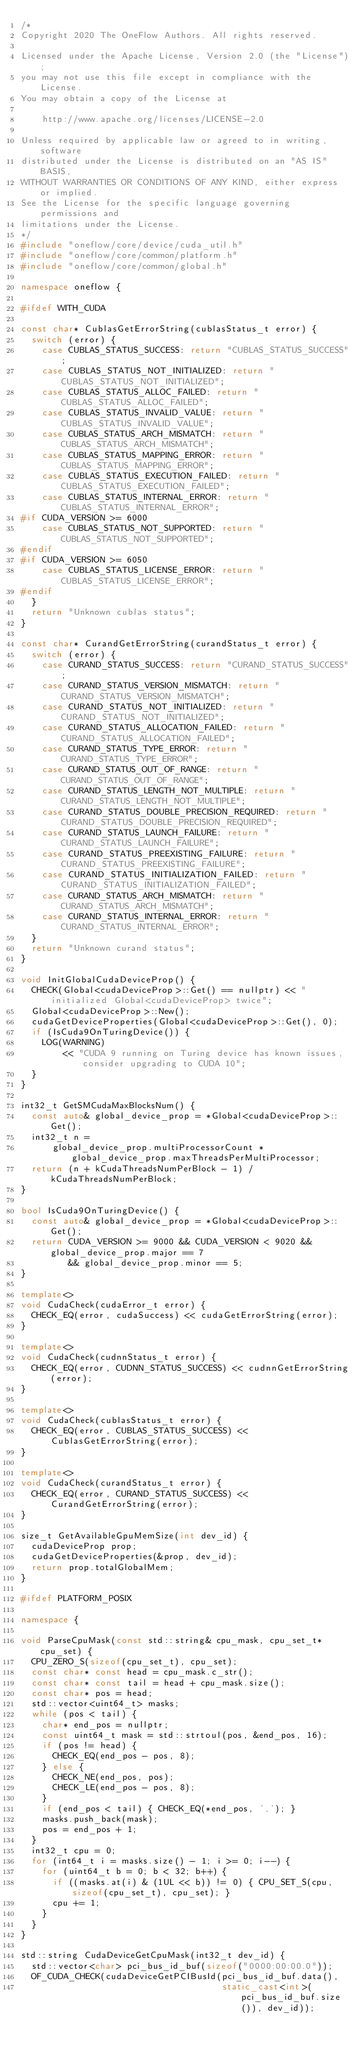Convert code to text. <code><loc_0><loc_0><loc_500><loc_500><_C++_>/*
Copyright 2020 The OneFlow Authors. All rights reserved.

Licensed under the Apache License, Version 2.0 (the "License");
you may not use this file except in compliance with the License.
You may obtain a copy of the License at

    http://www.apache.org/licenses/LICENSE-2.0

Unless required by applicable law or agreed to in writing, software
distributed under the License is distributed on an "AS IS" BASIS,
WITHOUT WARRANTIES OR CONDITIONS OF ANY KIND, either express or implied.
See the License for the specific language governing permissions and
limitations under the License.
*/
#include "oneflow/core/device/cuda_util.h"
#include "oneflow/core/common/platform.h"
#include "oneflow/core/common/global.h"

namespace oneflow {

#ifdef WITH_CUDA

const char* CublasGetErrorString(cublasStatus_t error) {
  switch (error) {
    case CUBLAS_STATUS_SUCCESS: return "CUBLAS_STATUS_SUCCESS";
    case CUBLAS_STATUS_NOT_INITIALIZED: return "CUBLAS_STATUS_NOT_INITIALIZED";
    case CUBLAS_STATUS_ALLOC_FAILED: return "CUBLAS_STATUS_ALLOC_FAILED";
    case CUBLAS_STATUS_INVALID_VALUE: return "CUBLAS_STATUS_INVALID_VALUE";
    case CUBLAS_STATUS_ARCH_MISMATCH: return "CUBLAS_STATUS_ARCH_MISMATCH";
    case CUBLAS_STATUS_MAPPING_ERROR: return "CUBLAS_STATUS_MAPPING_ERROR";
    case CUBLAS_STATUS_EXECUTION_FAILED: return "CUBLAS_STATUS_EXECUTION_FAILED";
    case CUBLAS_STATUS_INTERNAL_ERROR: return "CUBLAS_STATUS_INTERNAL_ERROR";
#if CUDA_VERSION >= 6000
    case CUBLAS_STATUS_NOT_SUPPORTED: return "CUBLAS_STATUS_NOT_SUPPORTED";
#endif
#if CUDA_VERSION >= 6050
    case CUBLAS_STATUS_LICENSE_ERROR: return "CUBLAS_STATUS_LICENSE_ERROR";
#endif
  }
  return "Unknown cublas status";
}

const char* CurandGetErrorString(curandStatus_t error) {
  switch (error) {
    case CURAND_STATUS_SUCCESS: return "CURAND_STATUS_SUCCESS";
    case CURAND_STATUS_VERSION_MISMATCH: return "CURAND_STATUS_VERSION_MISMATCH";
    case CURAND_STATUS_NOT_INITIALIZED: return "CURAND_STATUS_NOT_INITIALIZED";
    case CURAND_STATUS_ALLOCATION_FAILED: return "CURAND_STATUS_ALLOCATION_FAILED";
    case CURAND_STATUS_TYPE_ERROR: return "CURAND_STATUS_TYPE_ERROR";
    case CURAND_STATUS_OUT_OF_RANGE: return "CURAND_STATUS_OUT_OF_RANGE";
    case CURAND_STATUS_LENGTH_NOT_MULTIPLE: return "CURAND_STATUS_LENGTH_NOT_MULTIPLE";
    case CURAND_STATUS_DOUBLE_PRECISION_REQUIRED: return "CURAND_STATUS_DOUBLE_PRECISION_REQUIRED";
    case CURAND_STATUS_LAUNCH_FAILURE: return "CURAND_STATUS_LAUNCH_FAILURE";
    case CURAND_STATUS_PREEXISTING_FAILURE: return "CURAND_STATUS_PREEXISTING_FAILURE";
    case CURAND_STATUS_INITIALIZATION_FAILED: return "CURAND_STATUS_INITIALIZATION_FAILED";
    case CURAND_STATUS_ARCH_MISMATCH: return "CURAND_STATUS_ARCH_MISMATCH";
    case CURAND_STATUS_INTERNAL_ERROR: return "CURAND_STATUS_INTERNAL_ERROR";
  }
  return "Unknown curand status";
}

void InitGlobalCudaDeviceProp() {
  CHECK(Global<cudaDeviceProp>::Get() == nullptr) << "initialized Global<cudaDeviceProp> twice";
  Global<cudaDeviceProp>::New();
  cudaGetDeviceProperties(Global<cudaDeviceProp>::Get(), 0);
  if (IsCuda9OnTuringDevice()) {
    LOG(WARNING)
        << "CUDA 9 running on Turing device has known issues, consider upgrading to CUDA 10";
  }
}

int32_t GetSMCudaMaxBlocksNum() {
  const auto& global_device_prop = *Global<cudaDeviceProp>::Get();
  int32_t n =
      global_device_prop.multiProcessorCount * global_device_prop.maxThreadsPerMultiProcessor;
  return (n + kCudaThreadsNumPerBlock - 1) / kCudaThreadsNumPerBlock;
}

bool IsCuda9OnTuringDevice() {
  const auto& global_device_prop = *Global<cudaDeviceProp>::Get();
  return CUDA_VERSION >= 9000 && CUDA_VERSION < 9020 && global_device_prop.major == 7
         && global_device_prop.minor == 5;
}

template<>
void CudaCheck(cudaError_t error) {
  CHECK_EQ(error, cudaSuccess) << cudaGetErrorString(error);
}

template<>
void CudaCheck(cudnnStatus_t error) {
  CHECK_EQ(error, CUDNN_STATUS_SUCCESS) << cudnnGetErrorString(error);
}

template<>
void CudaCheck(cublasStatus_t error) {
  CHECK_EQ(error, CUBLAS_STATUS_SUCCESS) << CublasGetErrorString(error);
}

template<>
void CudaCheck(curandStatus_t error) {
  CHECK_EQ(error, CURAND_STATUS_SUCCESS) << CurandGetErrorString(error);
}

size_t GetAvailableGpuMemSize(int dev_id) {
  cudaDeviceProp prop;
  cudaGetDeviceProperties(&prop, dev_id);
  return prop.totalGlobalMem;
}

#ifdef PLATFORM_POSIX

namespace {

void ParseCpuMask(const std::string& cpu_mask, cpu_set_t* cpu_set) {
  CPU_ZERO_S(sizeof(cpu_set_t), cpu_set);
  const char* const head = cpu_mask.c_str();
  const char* const tail = head + cpu_mask.size();
  const char* pos = head;
  std::vector<uint64_t> masks;
  while (pos < tail) {
    char* end_pos = nullptr;
    const uint64_t mask = std::strtoul(pos, &end_pos, 16);
    if (pos != head) {
      CHECK_EQ(end_pos - pos, 8);
    } else {
      CHECK_NE(end_pos, pos);
      CHECK_LE(end_pos - pos, 8);
    }
    if (end_pos < tail) { CHECK_EQ(*end_pos, ','); }
    masks.push_back(mask);
    pos = end_pos + 1;
  }
  int32_t cpu = 0;
  for (int64_t i = masks.size() - 1; i >= 0; i--) {
    for (uint64_t b = 0; b < 32; b++) {
      if ((masks.at(i) & (1UL << b)) != 0) { CPU_SET_S(cpu, sizeof(cpu_set_t), cpu_set); }
      cpu += 1;
    }
  }
}

std::string CudaDeviceGetCpuMask(int32_t dev_id) {
  std::vector<char> pci_bus_id_buf(sizeof("0000:00:00.0"));
  OF_CUDA_CHECK(cudaDeviceGetPCIBusId(pci_bus_id_buf.data(),
                                      static_cast<int>(pci_bus_id_buf.size()), dev_id));</code> 